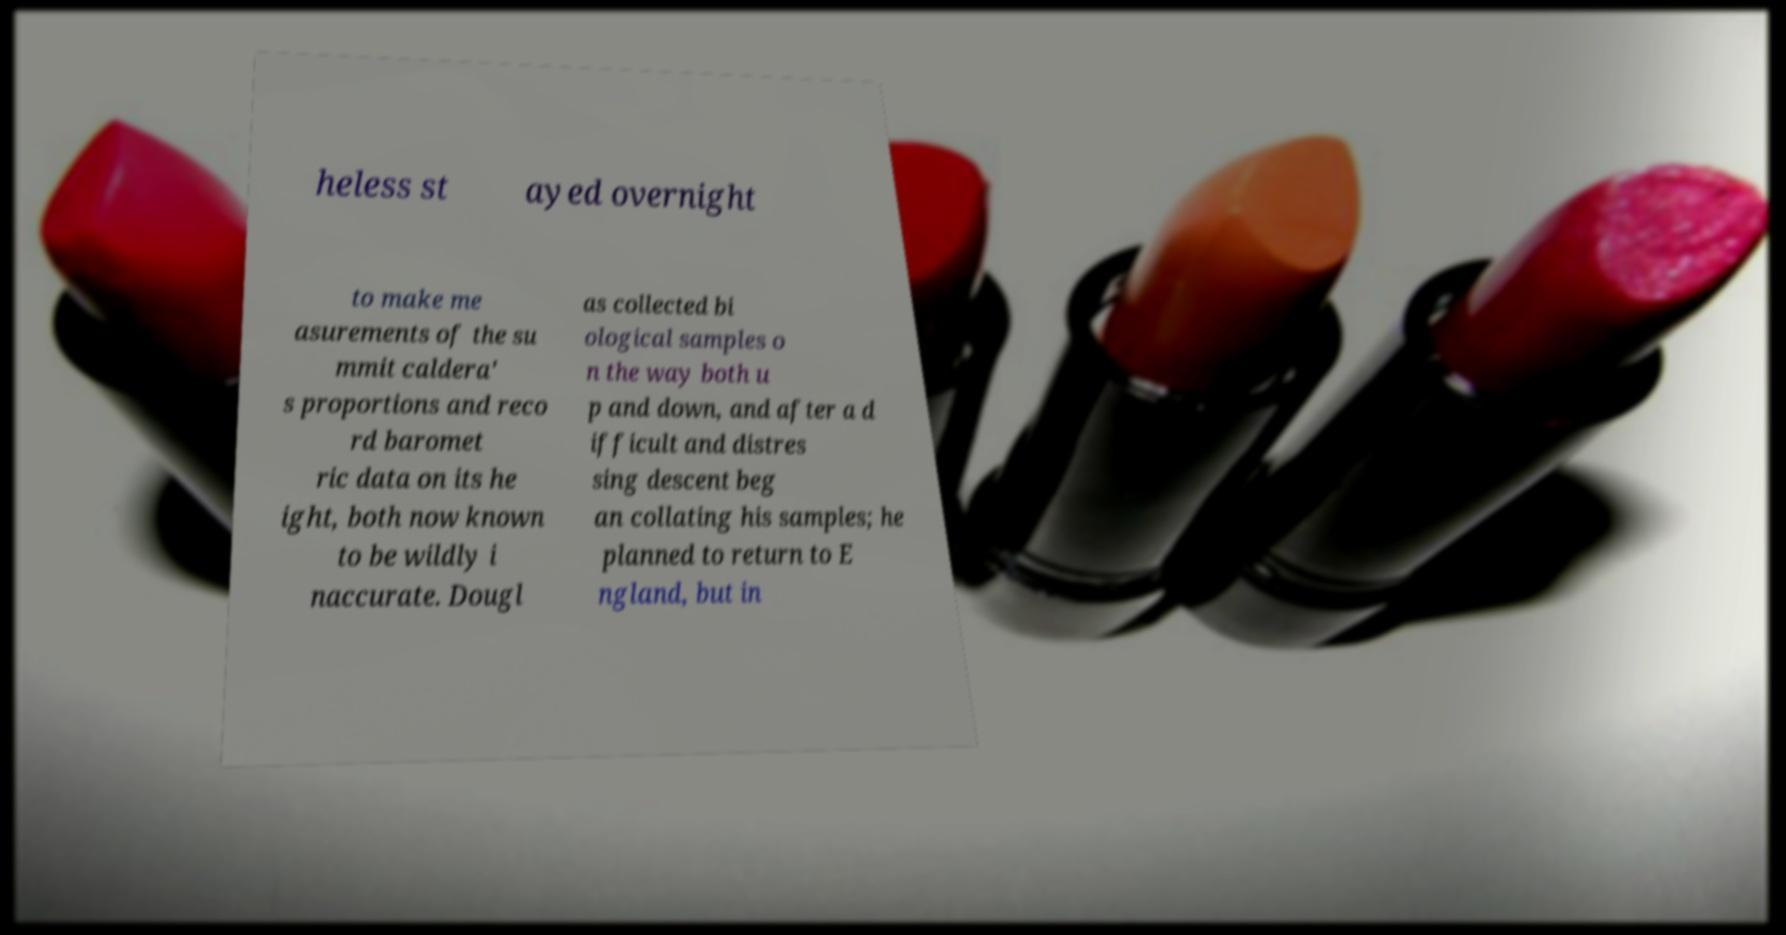Please identify and transcribe the text found in this image. heless st ayed overnight to make me asurements of the su mmit caldera' s proportions and reco rd baromet ric data on its he ight, both now known to be wildly i naccurate. Dougl as collected bi ological samples o n the way both u p and down, and after a d ifficult and distres sing descent beg an collating his samples; he planned to return to E ngland, but in 